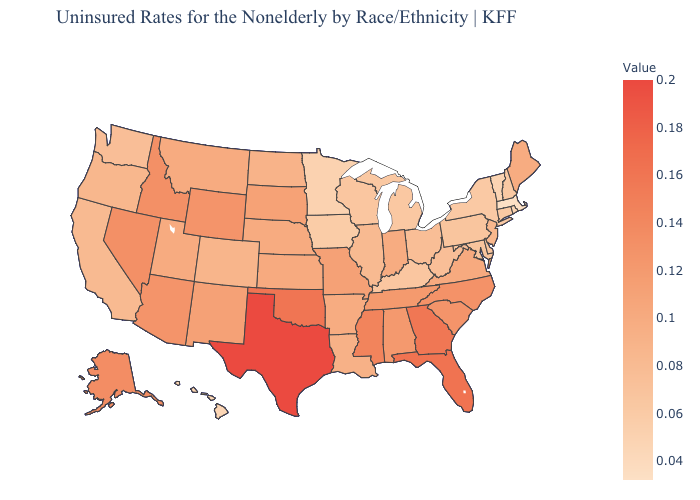Which states have the highest value in the USA?
Give a very brief answer. Texas. Does Massachusetts have the lowest value in the USA?
Be succinct. Yes. Among the states that border Georgia , which have the highest value?
Write a very short answer. Florida. Does Michigan have the highest value in the USA?
Answer briefly. No. Among the states that border Missouri , which have the lowest value?
Short answer required. Iowa. Does Arizona have the lowest value in the USA?
Write a very short answer. No. Does the map have missing data?
Concise answer only. No. 